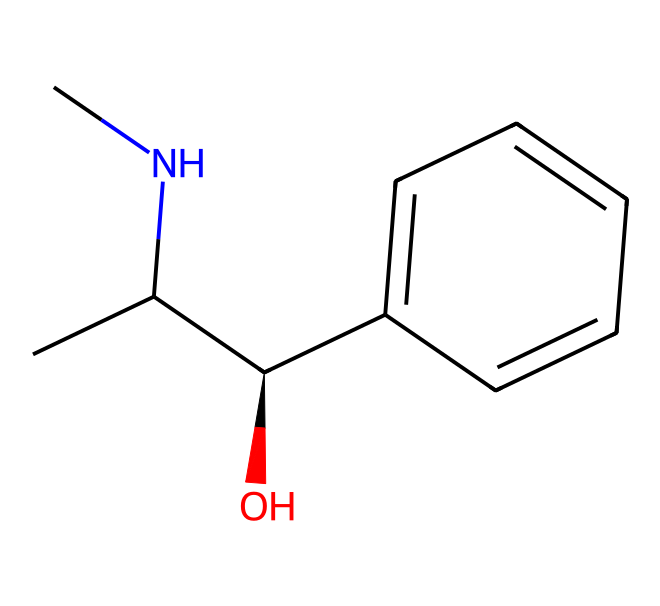What is the chemical name of this compound? The SMILES representation indicates the compound consists of specific structural components that correspond to ephedrine. Understanding the arrangement of atoms and their connectivity helps identify it.
Answer: ephedrine How many carbon atoms are present in the structure? By analyzing the SMILES notation, each 'C' represents a carbon atom. Counting the occurrences gives a total for the entire molecule.
Answer: 9 How many nitrogen atoms are in ephedrine? The `N` in the SMILES string indicates nitrogen. Scanning the structure reveals there is one nitrogen atom present in the entire molecule.
Answer: 1 What type of functional group is present in this chemical? The presence of the `-OH` group in the structure is indicative of an alcohol functional group, showing how it classifies this compound chemically.
Answer: alcohol What type of compounds do alkaloids typically contain? Alkaloids characteristically comprise nitrogen atoms, which are often found as part of their basic structures, such as in this case with ephedrine.
Answer: nitrogen Is ephedrine a natural or synthetic alkaloid? Ephedrine is derived from natural sources like the Ephedra plant, leading to its classification as a natural alkaloid.
Answer: natural What is a common use of ephedrine in dietary supplements? Ephedrine is commonly utilized in dietary supplements for its stimulant properties, particularly for enhancing energy and weight loss.
Answer: stimulant 